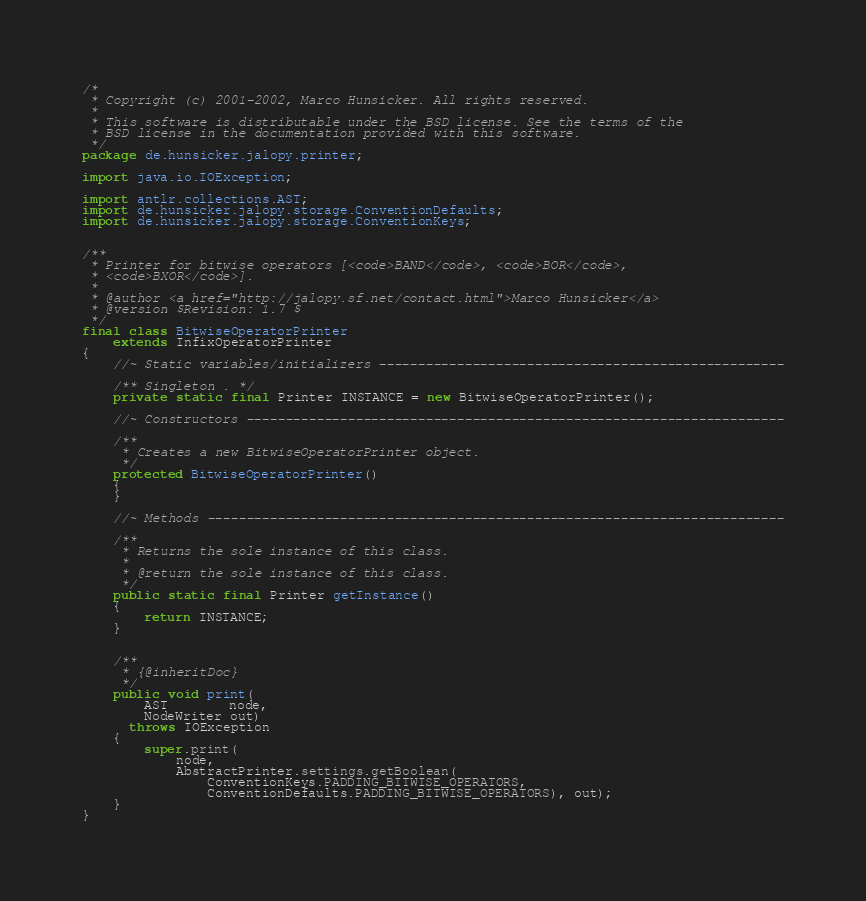Convert code to text. <code><loc_0><loc_0><loc_500><loc_500><_Java_>/*
 * Copyright (c) 2001-2002, Marco Hunsicker. All rights reserved.
 *
 * This software is distributable under the BSD license. See the terms of the
 * BSD license in the documentation provided with this software.
 */
package de.hunsicker.jalopy.printer;

import java.io.IOException;

import antlr.collections.AST;
import de.hunsicker.jalopy.storage.ConventionDefaults;
import de.hunsicker.jalopy.storage.ConventionKeys;


/**
 * Printer for bitwise operators [<code>BAND</code>, <code>BOR</code>,
 * <code>BXOR</code>].
 *
 * @author <a href="http://jalopy.sf.net/contact.html">Marco Hunsicker</a>
 * @version $Revision: 1.7 $
 */
final class BitwiseOperatorPrinter
    extends InfixOperatorPrinter
{
    //~ Static variables/initializers ----------------------------------------------------

    /** Singleton . */
    private static final Printer INSTANCE = new BitwiseOperatorPrinter();

    //~ Constructors ---------------------------------------------------------------------

    /**
     * Creates a new BitwiseOperatorPrinter object.
     */
    protected BitwiseOperatorPrinter()
    {
    }

    //~ Methods --------------------------------------------------------------------------

    /**
     * Returns the sole instance of this class.
     *
     * @return the sole instance of this class.
     */
    public static final Printer getInstance()
    {
        return INSTANCE;
    }


    /**
     * {@inheritDoc}
     */
    public void print(
        AST        node,
        NodeWriter out)
      throws IOException
    {
        super.print(
            node,
            AbstractPrinter.settings.getBoolean(
                ConventionKeys.PADDING_BITWISE_OPERATORS,
                ConventionDefaults.PADDING_BITWISE_OPERATORS), out);
    }
}
</code> 